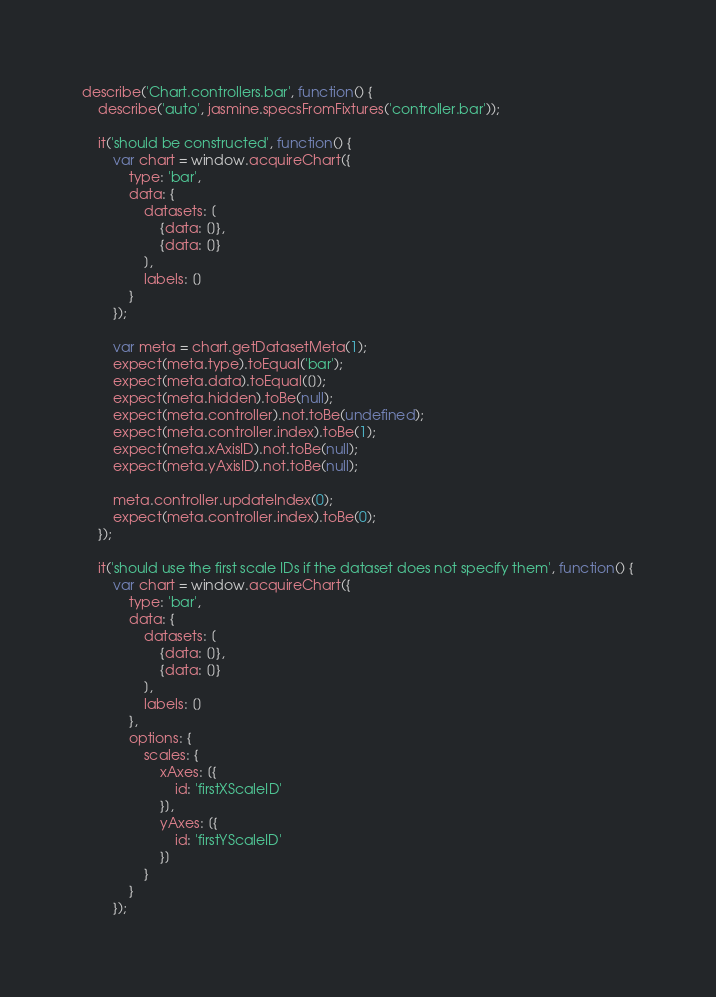<code> <loc_0><loc_0><loc_500><loc_500><_JavaScript_>describe('Chart.controllers.bar', function() {
	describe('auto', jasmine.specsFromFixtures('controller.bar'));

	it('should be constructed', function() {
		var chart = window.acquireChart({
			type: 'bar',
			data: {
				datasets: [
					{data: []},
					{data: []}
				],
				labels: []
			}
		});

		var meta = chart.getDatasetMeta(1);
		expect(meta.type).toEqual('bar');
		expect(meta.data).toEqual([]);
		expect(meta.hidden).toBe(null);
		expect(meta.controller).not.toBe(undefined);
		expect(meta.controller.index).toBe(1);
		expect(meta.xAxisID).not.toBe(null);
		expect(meta.yAxisID).not.toBe(null);

		meta.controller.updateIndex(0);
		expect(meta.controller.index).toBe(0);
	});

	it('should use the first scale IDs if the dataset does not specify them', function() {
		var chart = window.acquireChart({
			type: 'bar',
			data: {
				datasets: [
					{data: []},
					{data: []}
				],
				labels: []
			},
			options: {
				scales: {
					xAxes: [{
						id: 'firstXScaleID'
					}],
					yAxes: [{
						id: 'firstYScaleID'
					}]
				}
			}
		});
</code> 